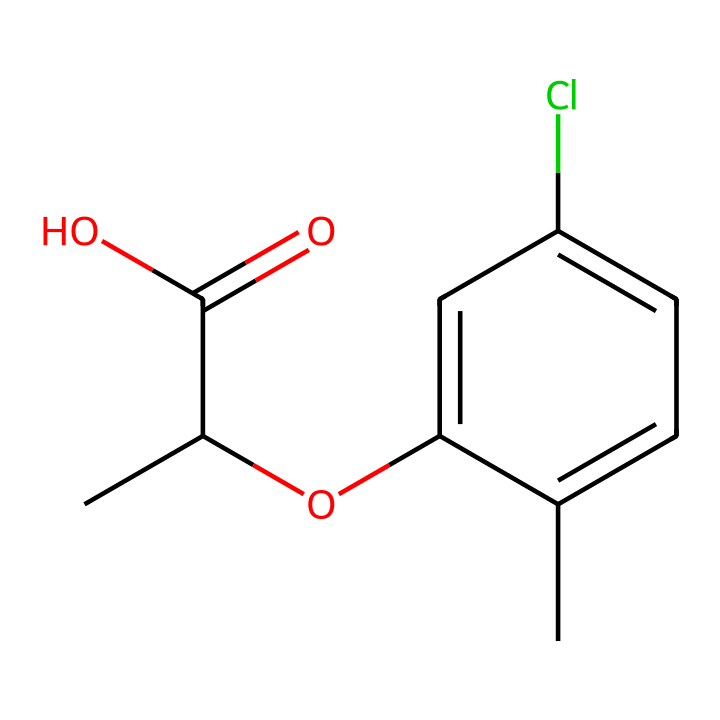What is the molecular formula of mecoprop? To derive the molecular formula, count the number of each type of atom in the SMILES representation. The structure indicates there are 10 carbon atoms, 11 hydrogen atoms, 2 oxygen atoms, and 1 chlorine atom. Thus, the molecular formula is C10H11ClO2.
Answer: C10H11ClO2 How many aromatic rings are present in this compound? Looking at the chemical structure, the presence of "c" in the SMILES representation indicates aromatic carbon atoms. There is one aromatic ring present linked to the aliphatic portion represented by aliphatic carbon "C".
Answer: one What is the significance of the chlorine atom in mecoprop? The chlorine atom is often responsible for the herbicidal properties of chemicals. It can enhance the biological activity of the compound, influencing how effectively it interacts with target plants.
Answer: herbicidal properties Which functional groups are present in mecoprop? From the SMILES notation, we can identify a carboxylic acid group (-COOH) and an ether group (indicated by "O"). These functional groups contribute to the chemical's overall behavior and interactions in the environment.
Answer: carboxylic acid, ether What is the likely pH range of a solution containing mecoprop? Considering that mecoprop contains a carboxylic acid functional group, it can donate protons in solution, thus the pH would likely be acidic. Typically, herbicides with similar structure tend to have a pH in the range of 4-7 when dissolved.
Answer: acidic Is mecoprop a selective or non-selective herbicide? Mecoprop is classified as a selective herbicide because it targets specific weeds without harming desired grasses and plants. This selectivity is partly due to its chemical structure and mode of action in plants.
Answer: selective What type of plants is mecoprop primarily effective against? Mecoprop is mainly effective against broadleaf weeds, which are not closely related to grass species. This is part of its selectivity as a herbicide.
Answer: broadleaf weeds 